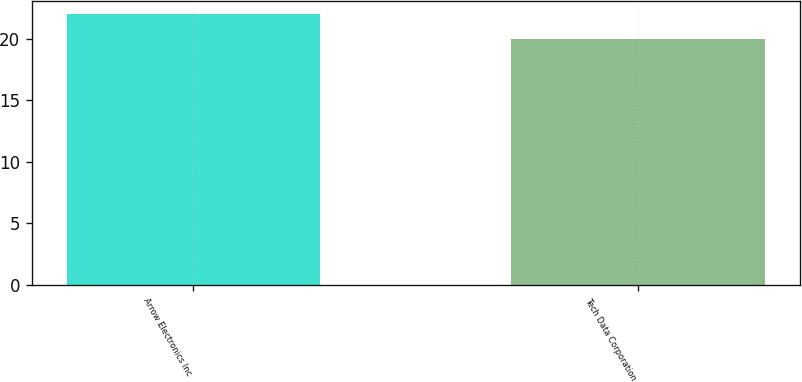<chart> <loc_0><loc_0><loc_500><loc_500><bar_chart><fcel>Arrow Electronics Inc<fcel>Tech Data Corporation<nl><fcel>22<fcel>20<nl></chart> 